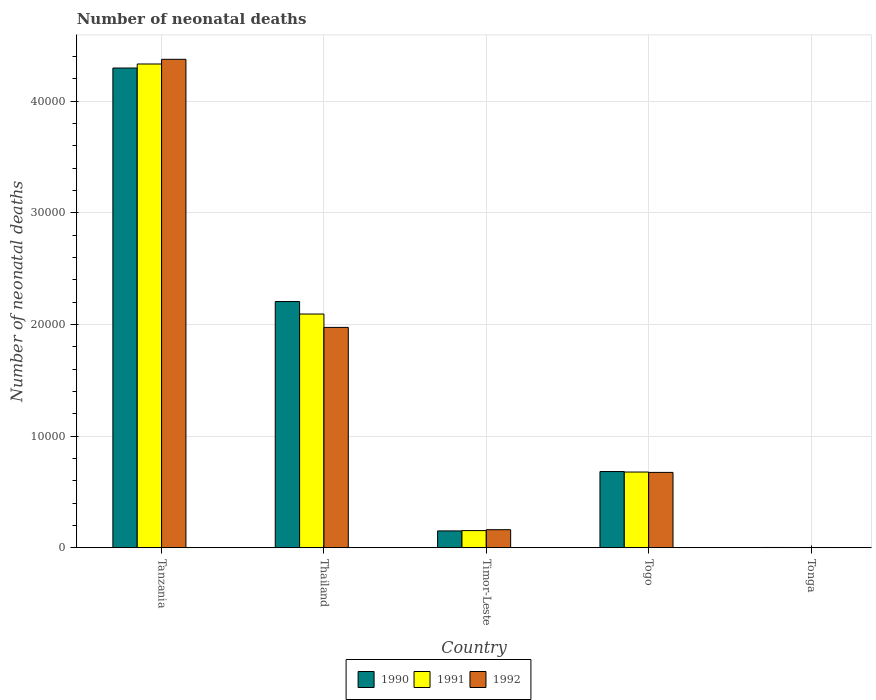How many different coloured bars are there?
Give a very brief answer. 3. How many groups of bars are there?
Give a very brief answer. 5. Are the number of bars per tick equal to the number of legend labels?
Keep it short and to the point. Yes. How many bars are there on the 4th tick from the right?
Ensure brevity in your answer.  3. What is the label of the 2nd group of bars from the left?
Give a very brief answer. Thailand. What is the number of neonatal deaths in in 1992 in Tonga?
Provide a short and direct response. 25. Across all countries, what is the maximum number of neonatal deaths in in 1991?
Your response must be concise. 4.33e+04. Across all countries, what is the minimum number of neonatal deaths in in 1992?
Your answer should be very brief. 25. In which country was the number of neonatal deaths in in 1990 maximum?
Ensure brevity in your answer.  Tanzania. In which country was the number of neonatal deaths in in 1992 minimum?
Provide a succinct answer. Tonga. What is the total number of neonatal deaths in in 1991 in the graph?
Keep it short and to the point. 7.26e+04. What is the difference between the number of neonatal deaths in in 1990 in Thailand and that in Tonga?
Offer a very short reply. 2.20e+04. What is the difference between the number of neonatal deaths in in 1991 in Tonga and the number of neonatal deaths in in 1990 in Tanzania?
Make the answer very short. -4.30e+04. What is the average number of neonatal deaths in in 1992 per country?
Give a very brief answer. 1.44e+04. What is the difference between the number of neonatal deaths in of/in 1992 and number of neonatal deaths in of/in 1990 in Thailand?
Ensure brevity in your answer.  -2316. In how many countries, is the number of neonatal deaths in in 1991 greater than 42000?
Your response must be concise. 1. What is the ratio of the number of neonatal deaths in in 1990 in Tanzania to that in Togo?
Give a very brief answer. 6.29. Is the number of neonatal deaths in in 1991 in Tanzania less than that in Thailand?
Provide a succinct answer. No. Is the difference between the number of neonatal deaths in in 1992 in Togo and Tonga greater than the difference between the number of neonatal deaths in in 1990 in Togo and Tonga?
Your response must be concise. No. What is the difference between the highest and the second highest number of neonatal deaths in in 1990?
Keep it short and to the point. 2.09e+04. What is the difference between the highest and the lowest number of neonatal deaths in in 1992?
Give a very brief answer. 4.37e+04. Is the sum of the number of neonatal deaths in in 1990 in Timor-Leste and Togo greater than the maximum number of neonatal deaths in in 1992 across all countries?
Offer a very short reply. No. What does the 1st bar from the left in Timor-Leste represents?
Make the answer very short. 1990. Is it the case that in every country, the sum of the number of neonatal deaths in in 1992 and number of neonatal deaths in in 1991 is greater than the number of neonatal deaths in in 1990?
Offer a very short reply. Yes. Are all the bars in the graph horizontal?
Make the answer very short. No. How many countries are there in the graph?
Provide a short and direct response. 5. What is the difference between two consecutive major ticks on the Y-axis?
Offer a terse response. 10000. What is the title of the graph?
Give a very brief answer. Number of neonatal deaths. What is the label or title of the Y-axis?
Provide a short and direct response. Number of neonatal deaths. What is the Number of neonatal deaths of 1990 in Tanzania?
Make the answer very short. 4.30e+04. What is the Number of neonatal deaths in 1991 in Tanzania?
Offer a terse response. 4.33e+04. What is the Number of neonatal deaths of 1992 in Tanzania?
Offer a terse response. 4.38e+04. What is the Number of neonatal deaths in 1990 in Thailand?
Your response must be concise. 2.21e+04. What is the Number of neonatal deaths in 1991 in Thailand?
Offer a terse response. 2.09e+04. What is the Number of neonatal deaths in 1992 in Thailand?
Offer a terse response. 1.97e+04. What is the Number of neonatal deaths of 1990 in Timor-Leste?
Offer a terse response. 1510. What is the Number of neonatal deaths of 1991 in Timor-Leste?
Give a very brief answer. 1537. What is the Number of neonatal deaths of 1992 in Timor-Leste?
Provide a succinct answer. 1618. What is the Number of neonatal deaths in 1990 in Togo?
Your answer should be very brief. 6828. What is the Number of neonatal deaths in 1991 in Togo?
Offer a terse response. 6783. What is the Number of neonatal deaths of 1992 in Togo?
Provide a short and direct response. 6751. What is the Number of neonatal deaths in 1990 in Tonga?
Offer a terse response. 26. What is the Number of neonatal deaths of 1992 in Tonga?
Make the answer very short. 25. Across all countries, what is the maximum Number of neonatal deaths of 1990?
Your answer should be compact. 4.30e+04. Across all countries, what is the maximum Number of neonatal deaths in 1991?
Provide a succinct answer. 4.33e+04. Across all countries, what is the maximum Number of neonatal deaths in 1992?
Your response must be concise. 4.38e+04. Across all countries, what is the minimum Number of neonatal deaths of 1992?
Offer a terse response. 25. What is the total Number of neonatal deaths of 1990 in the graph?
Your answer should be very brief. 7.34e+04. What is the total Number of neonatal deaths of 1991 in the graph?
Make the answer very short. 7.26e+04. What is the total Number of neonatal deaths of 1992 in the graph?
Ensure brevity in your answer.  7.19e+04. What is the difference between the Number of neonatal deaths of 1990 in Tanzania and that in Thailand?
Your answer should be very brief. 2.09e+04. What is the difference between the Number of neonatal deaths of 1991 in Tanzania and that in Thailand?
Your response must be concise. 2.24e+04. What is the difference between the Number of neonatal deaths of 1992 in Tanzania and that in Thailand?
Give a very brief answer. 2.40e+04. What is the difference between the Number of neonatal deaths of 1990 in Tanzania and that in Timor-Leste?
Your response must be concise. 4.15e+04. What is the difference between the Number of neonatal deaths in 1991 in Tanzania and that in Timor-Leste?
Your answer should be very brief. 4.18e+04. What is the difference between the Number of neonatal deaths of 1992 in Tanzania and that in Timor-Leste?
Provide a succinct answer. 4.21e+04. What is the difference between the Number of neonatal deaths of 1990 in Tanzania and that in Togo?
Give a very brief answer. 3.61e+04. What is the difference between the Number of neonatal deaths in 1991 in Tanzania and that in Togo?
Offer a very short reply. 3.66e+04. What is the difference between the Number of neonatal deaths in 1992 in Tanzania and that in Togo?
Offer a terse response. 3.70e+04. What is the difference between the Number of neonatal deaths in 1990 in Tanzania and that in Tonga?
Make the answer very short. 4.30e+04. What is the difference between the Number of neonatal deaths of 1991 in Tanzania and that in Tonga?
Keep it short and to the point. 4.33e+04. What is the difference between the Number of neonatal deaths in 1992 in Tanzania and that in Tonga?
Give a very brief answer. 4.37e+04. What is the difference between the Number of neonatal deaths of 1990 in Thailand and that in Timor-Leste?
Provide a short and direct response. 2.05e+04. What is the difference between the Number of neonatal deaths of 1991 in Thailand and that in Timor-Leste?
Your response must be concise. 1.94e+04. What is the difference between the Number of neonatal deaths in 1992 in Thailand and that in Timor-Leste?
Provide a short and direct response. 1.81e+04. What is the difference between the Number of neonatal deaths in 1990 in Thailand and that in Togo?
Your answer should be compact. 1.52e+04. What is the difference between the Number of neonatal deaths of 1991 in Thailand and that in Togo?
Your response must be concise. 1.42e+04. What is the difference between the Number of neonatal deaths of 1992 in Thailand and that in Togo?
Give a very brief answer. 1.30e+04. What is the difference between the Number of neonatal deaths of 1990 in Thailand and that in Tonga?
Make the answer very short. 2.20e+04. What is the difference between the Number of neonatal deaths in 1991 in Thailand and that in Tonga?
Your answer should be compact. 2.09e+04. What is the difference between the Number of neonatal deaths in 1992 in Thailand and that in Tonga?
Offer a very short reply. 1.97e+04. What is the difference between the Number of neonatal deaths of 1990 in Timor-Leste and that in Togo?
Your answer should be compact. -5318. What is the difference between the Number of neonatal deaths in 1991 in Timor-Leste and that in Togo?
Give a very brief answer. -5246. What is the difference between the Number of neonatal deaths of 1992 in Timor-Leste and that in Togo?
Offer a terse response. -5133. What is the difference between the Number of neonatal deaths in 1990 in Timor-Leste and that in Tonga?
Provide a succinct answer. 1484. What is the difference between the Number of neonatal deaths in 1991 in Timor-Leste and that in Tonga?
Provide a succinct answer. 1512. What is the difference between the Number of neonatal deaths of 1992 in Timor-Leste and that in Tonga?
Give a very brief answer. 1593. What is the difference between the Number of neonatal deaths of 1990 in Togo and that in Tonga?
Your answer should be compact. 6802. What is the difference between the Number of neonatal deaths in 1991 in Togo and that in Tonga?
Offer a very short reply. 6758. What is the difference between the Number of neonatal deaths of 1992 in Togo and that in Tonga?
Keep it short and to the point. 6726. What is the difference between the Number of neonatal deaths in 1990 in Tanzania and the Number of neonatal deaths in 1991 in Thailand?
Your answer should be compact. 2.20e+04. What is the difference between the Number of neonatal deaths in 1990 in Tanzania and the Number of neonatal deaths in 1992 in Thailand?
Offer a very short reply. 2.32e+04. What is the difference between the Number of neonatal deaths of 1991 in Tanzania and the Number of neonatal deaths of 1992 in Thailand?
Your answer should be compact. 2.36e+04. What is the difference between the Number of neonatal deaths of 1990 in Tanzania and the Number of neonatal deaths of 1991 in Timor-Leste?
Ensure brevity in your answer.  4.14e+04. What is the difference between the Number of neonatal deaths in 1990 in Tanzania and the Number of neonatal deaths in 1992 in Timor-Leste?
Provide a succinct answer. 4.14e+04. What is the difference between the Number of neonatal deaths of 1991 in Tanzania and the Number of neonatal deaths of 1992 in Timor-Leste?
Provide a short and direct response. 4.17e+04. What is the difference between the Number of neonatal deaths of 1990 in Tanzania and the Number of neonatal deaths of 1991 in Togo?
Provide a succinct answer. 3.62e+04. What is the difference between the Number of neonatal deaths of 1990 in Tanzania and the Number of neonatal deaths of 1992 in Togo?
Ensure brevity in your answer.  3.62e+04. What is the difference between the Number of neonatal deaths of 1991 in Tanzania and the Number of neonatal deaths of 1992 in Togo?
Offer a terse response. 3.66e+04. What is the difference between the Number of neonatal deaths in 1990 in Tanzania and the Number of neonatal deaths in 1991 in Tonga?
Keep it short and to the point. 4.30e+04. What is the difference between the Number of neonatal deaths of 1990 in Tanzania and the Number of neonatal deaths of 1992 in Tonga?
Make the answer very short. 4.30e+04. What is the difference between the Number of neonatal deaths of 1991 in Tanzania and the Number of neonatal deaths of 1992 in Tonga?
Your response must be concise. 4.33e+04. What is the difference between the Number of neonatal deaths in 1990 in Thailand and the Number of neonatal deaths in 1991 in Timor-Leste?
Provide a succinct answer. 2.05e+04. What is the difference between the Number of neonatal deaths in 1990 in Thailand and the Number of neonatal deaths in 1992 in Timor-Leste?
Provide a short and direct response. 2.04e+04. What is the difference between the Number of neonatal deaths of 1991 in Thailand and the Number of neonatal deaths of 1992 in Timor-Leste?
Give a very brief answer. 1.93e+04. What is the difference between the Number of neonatal deaths of 1990 in Thailand and the Number of neonatal deaths of 1991 in Togo?
Provide a succinct answer. 1.53e+04. What is the difference between the Number of neonatal deaths of 1990 in Thailand and the Number of neonatal deaths of 1992 in Togo?
Ensure brevity in your answer.  1.53e+04. What is the difference between the Number of neonatal deaths of 1991 in Thailand and the Number of neonatal deaths of 1992 in Togo?
Offer a very short reply. 1.42e+04. What is the difference between the Number of neonatal deaths of 1990 in Thailand and the Number of neonatal deaths of 1991 in Tonga?
Your answer should be compact. 2.20e+04. What is the difference between the Number of neonatal deaths in 1990 in Thailand and the Number of neonatal deaths in 1992 in Tonga?
Give a very brief answer. 2.20e+04. What is the difference between the Number of neonatal deaths of 1991 in Thailand and the Number of neonatal deaths of 1992 in Tonga?
Provide a succinct answer. 2.09e+04. What is the difference between the Number of neonatal deaths of 1990 in Timor-Leste and the Number of neonatal deaths of 1991 in Togo?
Provide a short and direct response. -5273. What is the difference between the Number of neonatal deaths of 1990 in Timor-Leste and the Number of neonatal deaths of 1992 in Togo?
Your answer should be compact. -5241. What is the difference between the Number of neonatal deaths of 1991 in Timor-Leste and the Number of neonatal deaths of 1992 in Togo?
Offer a very short reply. -5214. What is the difference between the Number of neonatal deaths in 1990 in Timor-Leste and the Number of neonatal deaths in 1991 in Tonga?
Ensure brevity in your answer.  1485. What is the difference between the Number of neonatal deaths of 1990 in Timor-Leste and the Number of neonatal deaths of 1992 in Tonga?
Make the answer very short. 1485. What is the difference between the Number of neonatal deaths of 1991 in Timor-Leste and the Number of neonatal deaths of 1992 in Tonga?
Provide a succinct answer. 1512. What is the difference between the Number of neonatal deaths of 1990 in Togo and the Number of neonatal deaths of 1991 in Tonga?
Offer a very short reply. 6803. What is the difference between the Number of neonatal deaths of 1990 in Togo and the Number of neonatal deaths of 1992 in Tonga?
Your answer should be very brief. 6803. What is the difference between the Number of neonatal deaths in 1991 in Togo and the Number of neonatal deaths in 1992 in Tonga?
Keep it short and to the point. 6758. What is the average Number of neonatal deaths in 1990 per country?
Provide a short and direct response. 1.47e+04. What is the average Number of neonatal deaths in 1991 per country?
Provide a short and direct response. 1.45e+04. What is the average Number of neonatal deaths in 1992 per country?
Your response must be concise. 1.44e+04. What is the difference between the Number of neonatal deaths of 1990 and Number of neonatal deaths of 1991 in Tanzania?
Provide a short and direct response. -362. What is the difference between the Number of neonatal deaths in 1990 and Number of neonatal deaths in 1992 in Tanzania?
Give a very brief answer. -782. What is the difference between the Number of neonatal deaths in 1991 and Number of neonatal deaths in 1992 in Tanzania?
Your answer should be very brief. -420. What is the difference between the Number of neonatal deaths in 1990 and Number of neonatal deaths in 1991 in Thailand?
Offer a terse response. 1118. What is the difference between the Number of neonatal deaths in 1990 and Number of neonatal deaths in 1992 in Thailand?
Offer a very short reply. 2316. What is the difference between the Number of neonatal deaths in 1991 and Number of neonatal deaths in 1992 in Thailand?
Make the answer very short. 1198. What is the difference between the Number of neonatal deaths in 1990 and Number of neonatal deaths in 1992 in Timor-Leste?
Offer a very short reply. -108. What is the difference between the Number of neonatal deaths in 1991 and Number of neonatal deaths in 1992 in Timor-Leste?
Offer a very short reply. -81. What is the difference between the Number of neonatal deaths in 1990 and Number of neonatal deaths in 1991 in Togo?
Give a very brief answer. 45. What is the difference between the Number of neonatal deaths of 1990 and Number of neonatal deaths of 1992 in Togo?
Offer a very short reply. 77. What is the difference between the Number of neonatal deaths of 1991 and Number of neonatal deaths of 1992 in Togo?
Offer a very short reply. 32. What is the difference between the Number of neonatal deaths in 1990 and Number of neonatal deaths in 1991 in Tonga?
Your answer should be very brief. 1. What is the difference between the Number of neonatal deaths of 1990 and Number of neonatal deaths of 1992 in Tonga?
Provide a short and direct response. 1. What is the difference between the Number of neonatal deaths of 1991 and Number of neonatal deaths of 1992 in Tonga?
Provide a succinct answer. 0. What is the ratio of the Number of neonatal deaths in 1990 in Tanzania to that in Thailand?
Ensure brevity in your answer.  1.95. What is the ratio of the Number of neonatal deaths in 1991 in Tanzania to that in Thailand?
Make the answer very short. 2.07. What is the ratio of the Number of neonatal deaths in 1992 in Tanzania to that in Thailand?
Provide a succinct answer. 2.22. What is the ratio of the Number of neonatal deaths in 1990 in Tanzania to that in Timor-Leste?
Provide a short and direct response. 28.46. What is the ratio of the Number of neonatal deaths of 1991 in Tanzania to that in Timor-Leste?
Make the answer very short. 28.2. What is the ratio of the Number of neonatal deaths of 1992 in Tanzania to that in Timor-Leste?
Make the answer very short. 27.04. What is the ratio of the Number of neonatal deaths of 1990 in Tanzania to that in Togo?
Keep it short and to the point. 6.29. What is the ratio of the Number of neonatal deaths of 1991 in Tanzania to that in Togo?
Make the answer very short. 6.39. What is the ratio of the Number of neonatal deaths in 1992 in Tanzania to that in Togo?
Provide a succinct answer. 6.48. What is the ratio of the Number of neonatal deaths of 1990 in Tanzania to that in Tonga?
Offer a very short reply. 1652.92. What is the ratio of the Number of neonatal deaths of 1991 in Tanzania to that in Tonga?
Make the answer very short. 1733.52. What is the ratio of the Number of neonatal deaths of 1992 in Tanzania to that in Tonga?
Offer a terse response. 1750.32. What is the ratio of the Number of neonatal deaths in 1990 in Thailand to that in Timor-Leste?
Provide a succinct answer. 14.61. What is the ratio of the Number of neonatal deaths of 1991 in Thailand to that in Timor-Leste?
Make the answer very short. 13.62. What is the ratio of the Number of neonatal deaths of 1992 in Thailand to that in Timor-Leste?
Your response must be concise. 12.2. What is the ratio of the Number of neonatal deaths in 1990 in Thailand to that in Togo?
Your answer should be compact. 3.23. What is the ratio of the Number of neonatal deaths in 1991 in Thailand to that in Togo?
Give a very brief answer. 3.09. What is the ratio of the Number of neonatal deaths of 1992 in Thailand to that in Togo?
Your response must be concise. 2.92. What is the ratio of the Number of neonatal deaths in 1990 in Thailand to that in Tonga?
Offer a terse response. 848.35. What is the ratio of the Number of neonatal deaths in 1991 in Thailand to that in Tonga?
Keep it short and to the point. 837.56. What is the ratio of the Number of neonatal deaths of 1992 in Thailand to that in Tonga?
Give a very brief answer. 789.64. What is the ratio of the Number of neonatal deaths in 1990 in Timor-Leste to that in Togo?
Offer a terse response. 0.22. What is the ratio of the Number of neonatal deaths of 1991 in Timor-Leste to that in Togo?
Keep it short and to the point. 0.23. What is the ratio of the Number of neonatal deaths in 1992 in Timor-Leste to that in Togo?
Offer a very short reply. 0.24. What is the ratio of the Number of neonatal deaths of 1990 in Timor-Leste to that in Tonga?
Offer a very short reply. 58.08. What is the ratio of the Number of neonatal deaths in 1991 in Timor-Leste to that in Tonga?
Give a very brief answer. 61.48. What is the ratio of the Number of neonatal deaths of 1992 in Timor-Leste to that in Tonga?
Your answer should be compact. 64.72. What is the ratio of the Number of neonatal deaths of 1990 in Togo to that in Tonga?
Make the answer very short. 262.62. What is the ratio of the Number of neonatal deaths in 1991 in Togo to that in Tonga?
Provide a short and direct response. 271.32. What is the ratio of the Number of neonatal deaths of 1992 in Togo to that in Tonga?
Provide a succinct answer. 270.04. What is the difference between the highest and the second highest Number of neonatal deaths in 1990?
Provide a short and direct response. 2.09e+04. What is the difference between the highest and the second highest Number of neonatal deaths in 1991?
Your answer should be very brief. 2.24e+04. What is the difference between the highest and the second highest Number of neonatal deaths of 1992?
Your answer should be compact. 2.40e+04. What is the difference between the highest and the lowest Number of neonatal deaths of 1990?
Your response must be concise. 4.30e+04. What is the difference between the highest and the lowest Number of neonatal deaths in 1991?
Your answer should be very brief. 4.33e+04. What is the difference between the highest and the lowest Number of neonatal deaths of 1992?
Keep it short and to the point. 4.37e+04. 